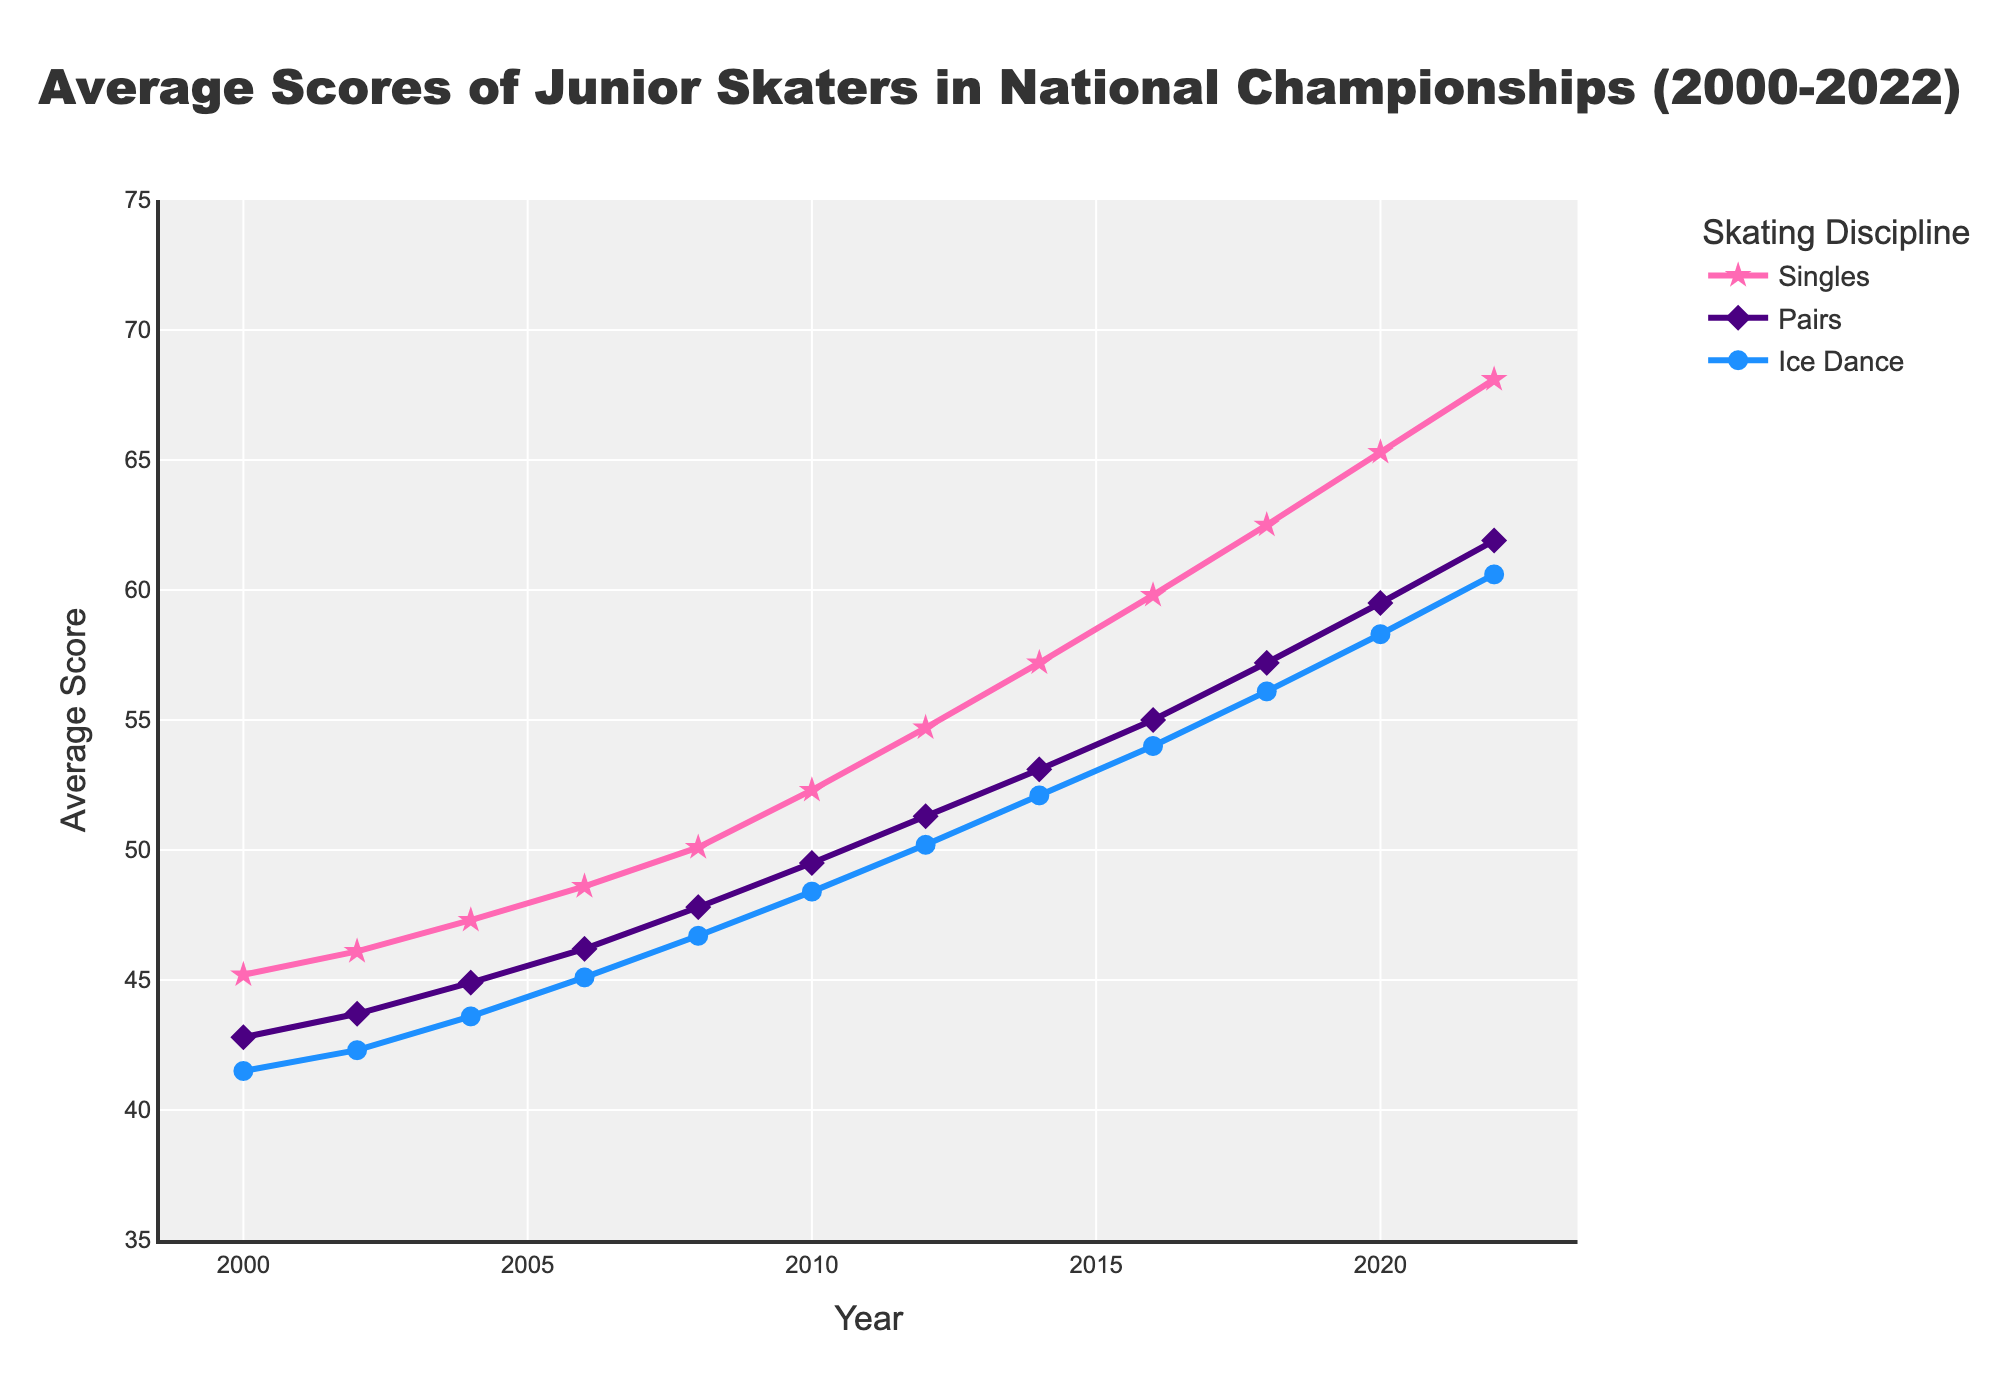What is the average score for Singles in 2020? To find the average score for Singles in 2020, look at the data for that year under the "Singles" category. The chart shows this value as 65.3.
Answer: 65.3 Which discipline had the highest average score in 2018? Compare the scores for all three disciplines in 2018. Singles scored 62.5, Pairs scored 57.2, and Ice Dance scored 56.1. The highest score is in the Singles category.
Answer: Singles How did the average score of Pairs change from 2004 to 2006? Find the scores for Pairs in 2004 (44.9) and 2006 (46.2). Calculate the difference: 46.2 - 44.9 = 1.3.
Answer: Increased by 1.3 What was the general trend for Ice Dance scores from 2000 to 2022? Observe the Ice Dance line, which steadily rises from 41.5 in 2000 to 60.6 in 2022, indicating a general upward trend.
Answer: Upward trend How many points did the average Singles score increase from 2000 to 2022? Find the difference between the 2000 value (45.2) and the 2022 value (68.1). The increase is 68.1 - 45.2 = 22.9 points.
Answer: 22.9 points Which year showed the smallest gap between Singles and Pairs scores? Calculate the differences between Singles and Pairs scores for each year and find the smallest one. E.g., in 2000, the gap is 45.2 - 42.8 = 2.4. Comparing all the years, the smallest gap is in 2022 with 68.1 - 61.9 = 6.2.
Answer: 2000 Did the Ice Dance scores ever surpass Pairs scores? If so, in which year(s)? Compare Ice Dance and Pairs scores for all years. Ice Dance never surpassed Pairs in any year according to the chart.
Answer: No, never surpassed What is the overall increase in the average Ice Dance scores from 2008 to 2022? Subtract the Ice Dance score in 2008 (46.7) from the score in 2022 (60.6): 60.6 - 46.7 = 13.9.
Answer: 13.9 In which year did the Singles score first exceed 50 points? Trace the Singles scores year by year. The score exceeded 50 points for the first time in 2010 (52.3).
Answer: 2010 Compare the rate of increase in the average scores for Singles and Pairs between 2010 and 2020. Calculate the increase for both: Singles (65.3 - 52.3 = 13) and Pairs (59.5 - 49.5 = 10). Singles increased by 13, while Pairs increased by 10.
Answer: Singles increased faster 